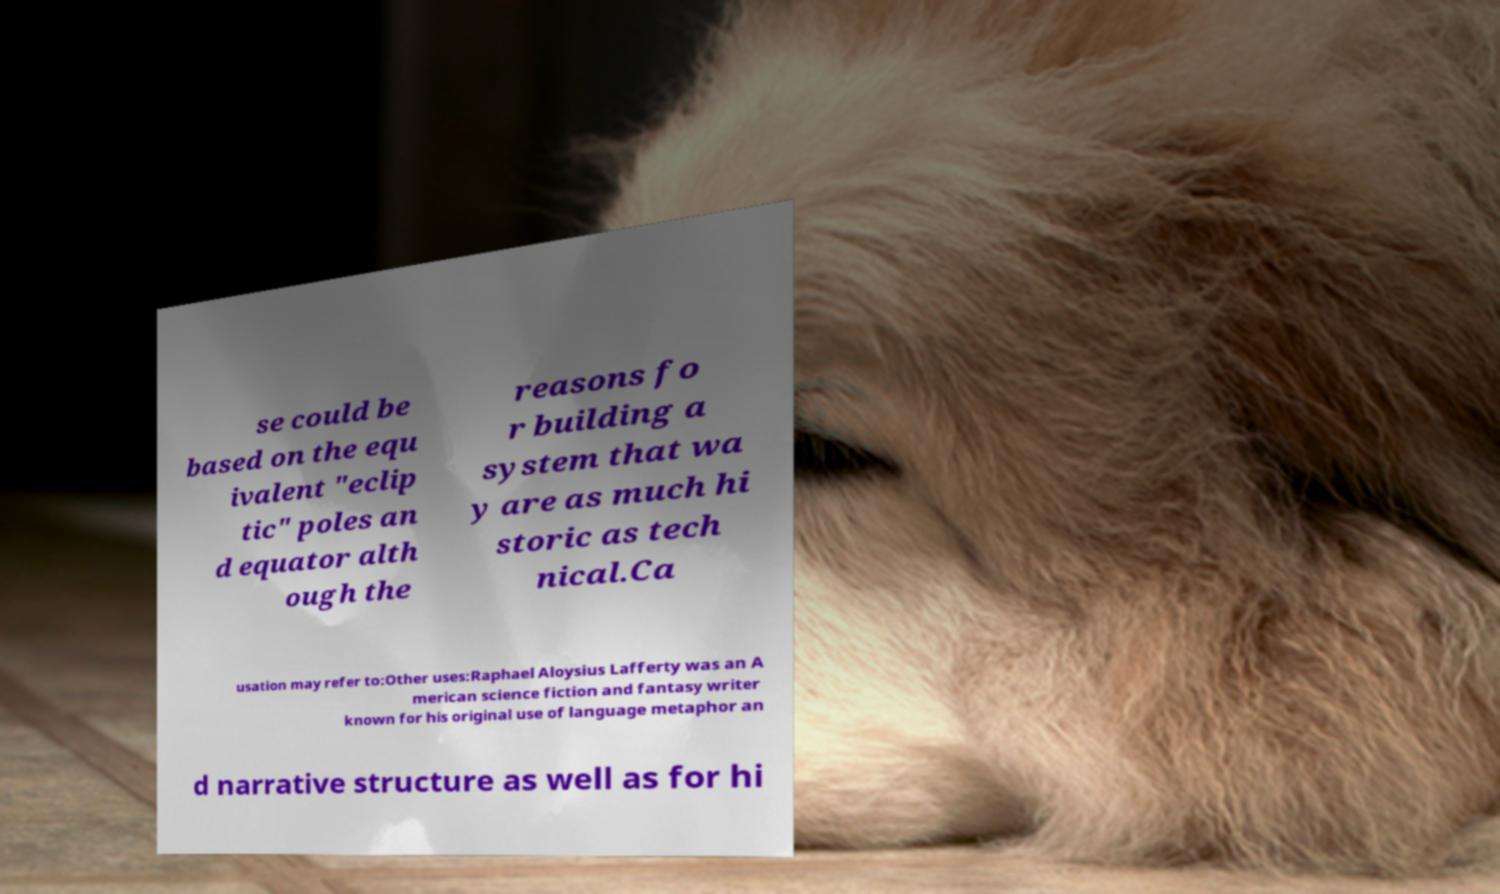What messages or text are displayed in this image? I need them in a readable, typed format. se could be based on the equ ivalent "eclip tic" poles an d equator alth ough the reasons fo r building a system that wa y are as much hi storic as tech nical.Ca usation may refer to:Other uses:Raphael Aloysius Lafferty was an A merican science fiction and fantasy writer known for his original use of language metaphor an d narrative structure as well as for hi 